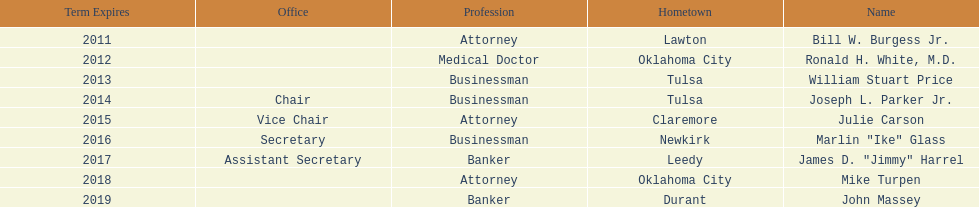Other than william stuart price, which other businessman was born in tulsa? Joseph L. Parker Jr. 